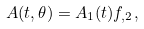Convert formula to latex. <formula><loc_0><loc_0><loc_500><loc_500>A ( t , \theta ) = A _ { 1 } ( t ) f _ { , 2 } ,</formula> 